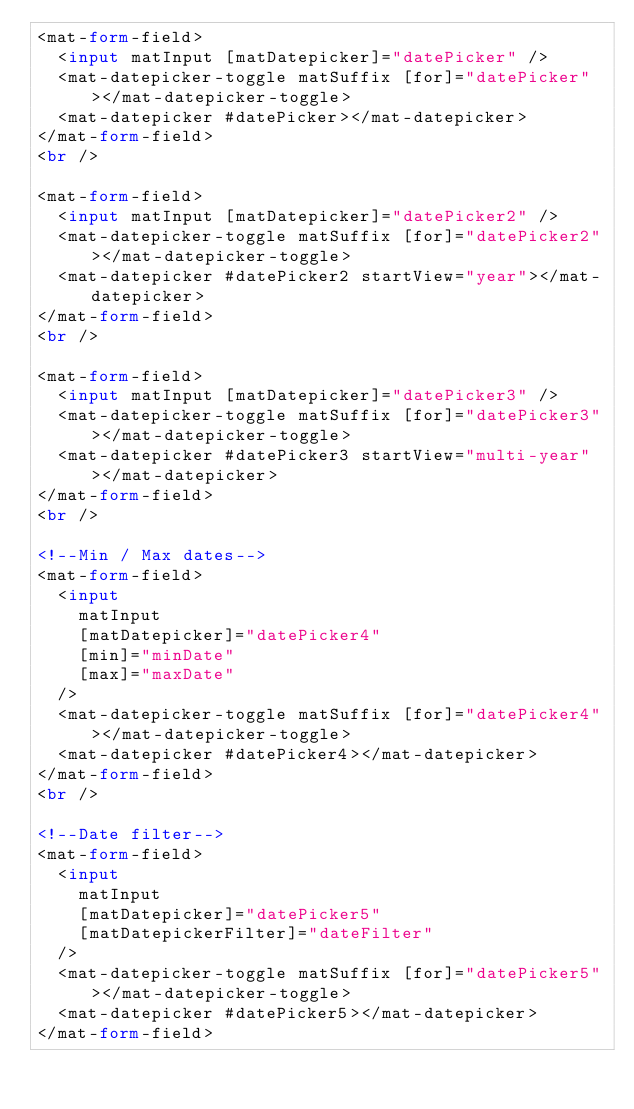<code> <loc_0><loc_0><loc_500><loc_500><_HTML_><mat-form-field>
  <input matInput [matDatepicker]="datePicker" />
  <mat-datepicker-toggle matSuffix [for]="datePicker"></mat-datepicker-toggle>
  <mat-datepicker #datePicker></mat-datepicker>
</mat-form-field>
<br />

<mat-form-field>
  <input matInput [matDatepicker]="datePicker2" />
  <mat-datepicker-toggle matSuffix [for]="datePicker2"></mat-datepicker-toggle>
  <mat-datepicker #datePicker2 startView="year"></mat-datepicker>
</mat-form-field>
<br />

<mat-form-field>
  <input matInput [matDatepicker]="datePicker3" />
  <mat-datepicker-toggle matSuffix [for]="datePicker3"></mat-datepicker-toggle>
  <mat-datepicker #datePicker3 startView="multi-year"></mat-datepicker>
</mat-form-field>
<br />

<!--Min / Max dates-->
<mat-form-field>
  <input
    matInput
    [matDatepicker]="datePicker4"
    [min]="minDate"
    [max]="maxDate"
  />
  <mat-datepicker-toggle matSuffix [for]="datePicker4"></mat-datepicker-toggle>
  <mat-datepicker #datePicker4></mat-datepicker>
</mat-form-field>
<br />

<!--Date filter-->
<mat-form-field>
  <input
    matInput
    [matDatepicker]="datePicker5"
    [matDatepickerFilter]="dateFilter"
  />
  <mat-datepicker-toggle matSuffix [for]="datePicker5"></mat-datepicker-toggle>
  <mat-datepicker #datePicker5></mat-datepicker>
</mat-form-field>
</code> 